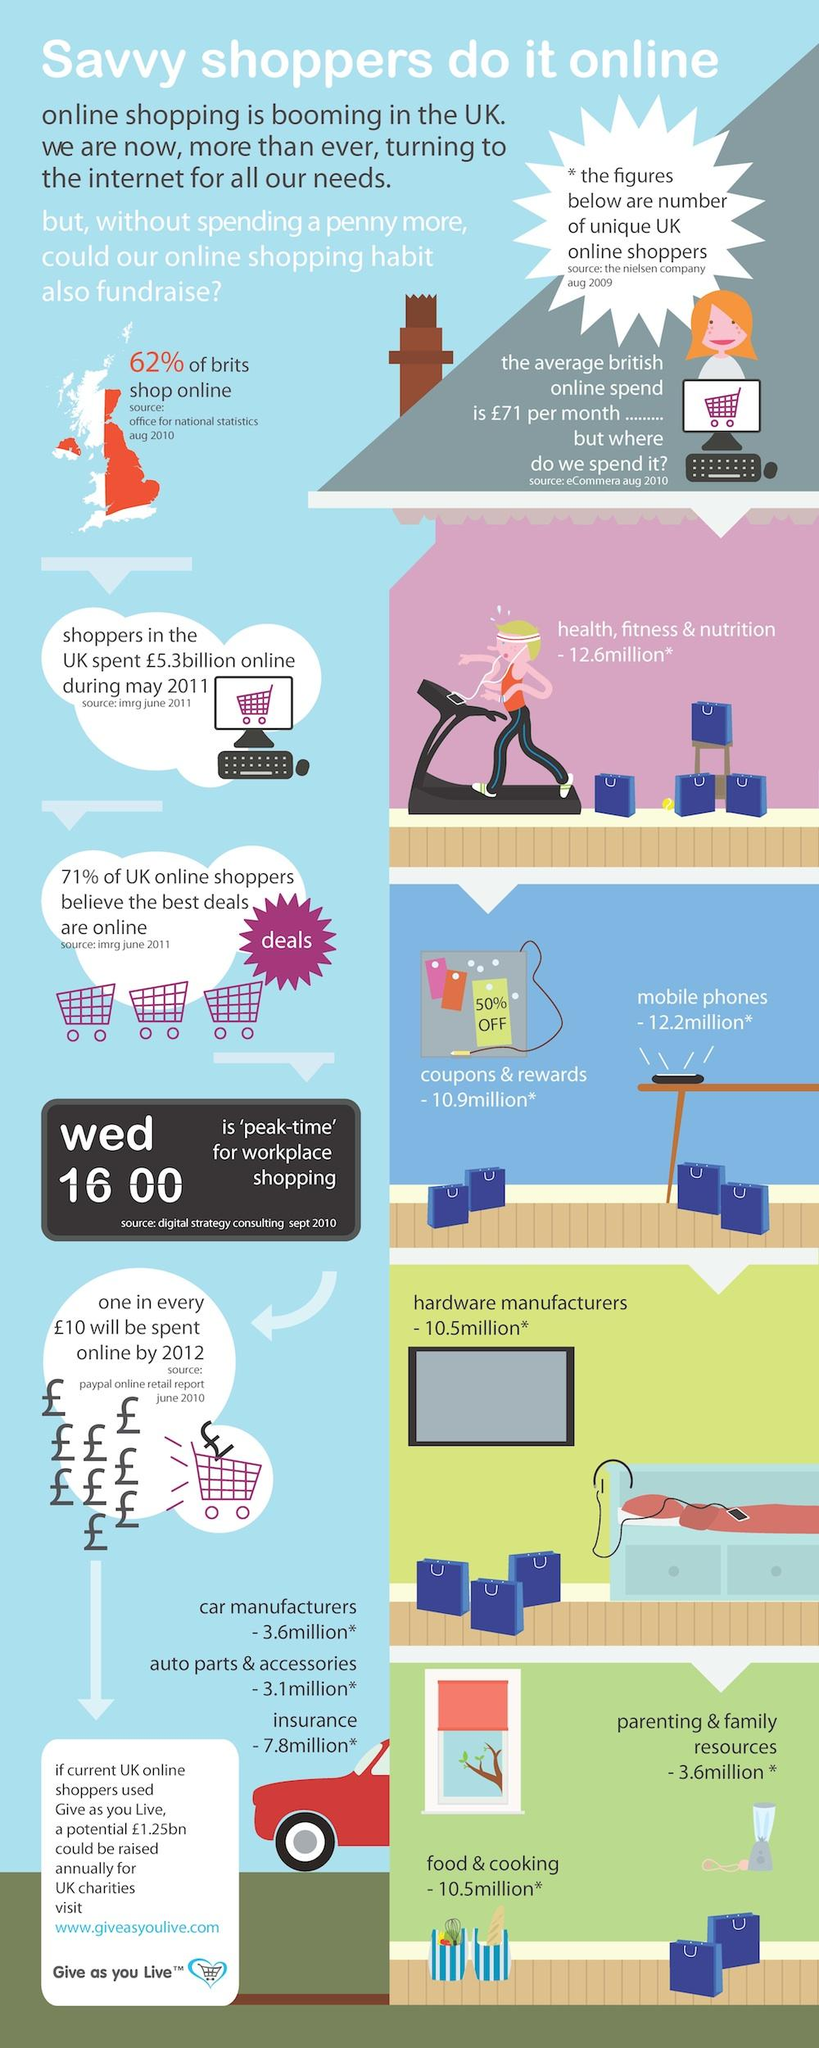Outline some significant characteristics in this image. The value of insurance has been estimated to be 7.8 million.* The spending on mobile phones is estimated to be 12.2 million. The total spend on parenting and family resources, as well as food and cooking, amounted to 14.1 million. According to the data, the spend on health, fitness, and nutrition is estimated to be 12.6 million... By 2012, it is projected that a significant percentage of the money spent will be spent online. 